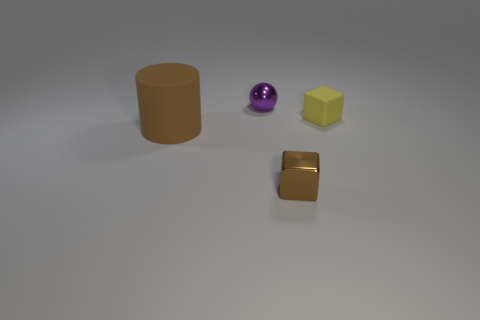Is the number of brown blocks that are behind the small purple thing greater than the number of small red blocks?
Provide a succinct answer. No. The small metal object that is in front of the rubber thing to the left of the small cube that is right of the small brown thing is what shape?
Your answer should be compact. Cube. There is a brown thing right of the small purple thing; is it the same shape as the small object that is behind the small matte object?
Keep it short and to the point. No. Is there any other thing that has the same size as the matte block?
Your answer should be compact. Yes. How many balls are tiny brown matte things or tiny yellow matte objects?
Your answer should be very brief. 0. Does the purple thing have the same material as the large object?
Provide a succinct answer. No. How many other objects are there of the same color as the rubber cylinder?
Offer a terse response. 1. What shape is the rubber object in front of the tiny matte thing?
Offer a very short reply. Cylinder. What number of objects are tiny purple objects or large brown things?
Your response must be concise. 2. There is a brown cylinder; is its size the same as the brown block in front of the yellow matte cube?
Provide a short and direct response. No. 